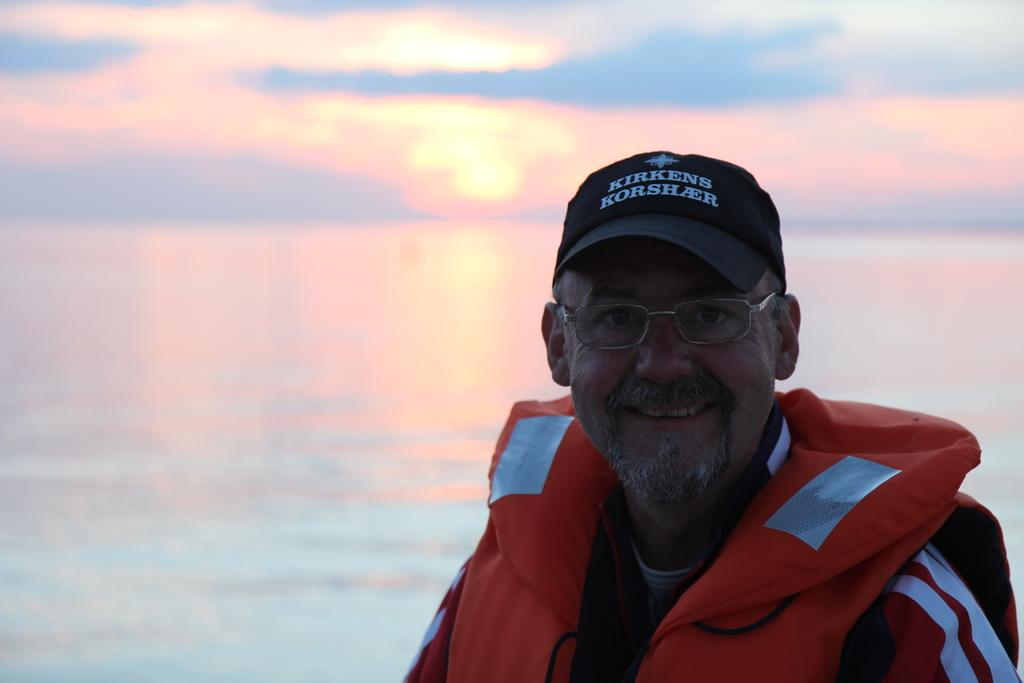What can be seen in the image? There is a person in the image. Can you describe the person's appearance? The person is wearing spectacles and a cap. What is visible in the background of the image? Water and the sky are visible in the image. What is the condition of the sky in the image? Clouds are present in the sky. What type of fish can be seen swimming in the water in the image? There are no fish visible in the image; only water is present. What kind of jewel is the person wearing around their neck in the image? The person is not wearing any jewelry, such as a collar or a jewel, in the image. 